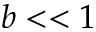Convert formula to latex. <formula><loc_0><loc_0><loc_500><loc_500>b < < 1</formula> 